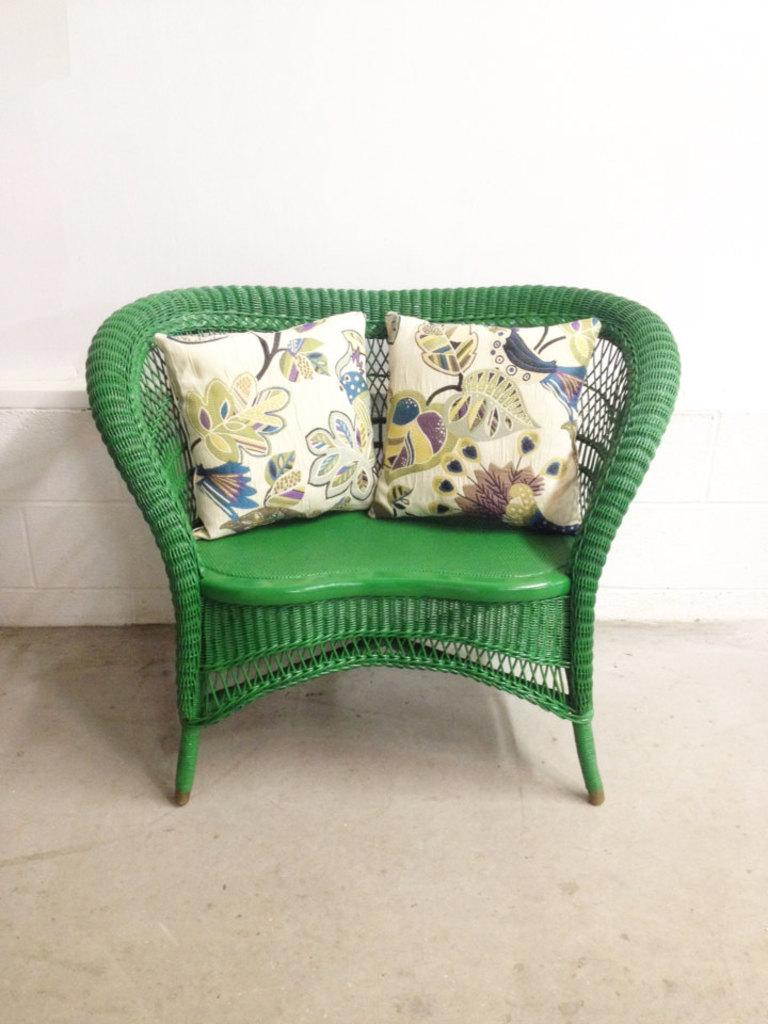What is located in the center of the image? There is an empty chair in the center of the image. What can be seen on the chair? The chair has two cushions on it. How does the jelly interact with the chair in the image? There is no jelly present in the image, so it cannot interact with the chair. 